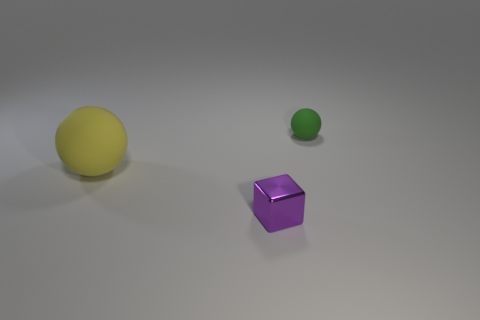Is the shape of the small metallic thing the same as the rubber thing on the left side of the small green rubber ball?
Make the answer very short. No. How big is the yellow thing?
Make the answer very short. Large. Are there fewer tiny green rubber objects that are in front of the purple cube than brown objects?
Provide a short and direct response. No. How many yellow rubber spheres are the same size as the green object?
Keep it short and to the point. 0. There is a rubber sphere that is left of the tiny green ball; does it have the same color as the matte object that is to the right of the big rubber object?
Make the answer very short. No. How many matte balls are to the left of the tiny green object?
Give a very brief answer. 1. Is there another large matte object that has the same shape as the purple object?
Offer a terse response. No. There is a object that is the same size as the green matte ball; what is its color?
Your answer should be compact. Purple. Is the number of green objects that are in front of the big thing less than the number of green objects to the left of the tiny metal cube?
Your answer should be very brief. No. There is a sphere that is right of the purple shiny block; does it have the same size as the yellow thing?
Make the answer very short. No. 